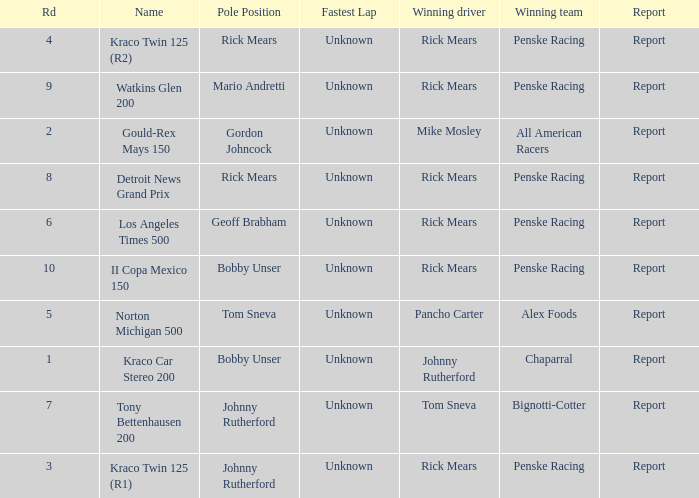What are the races that johnny rutherford has won? Kraco Car Stereo 200. 